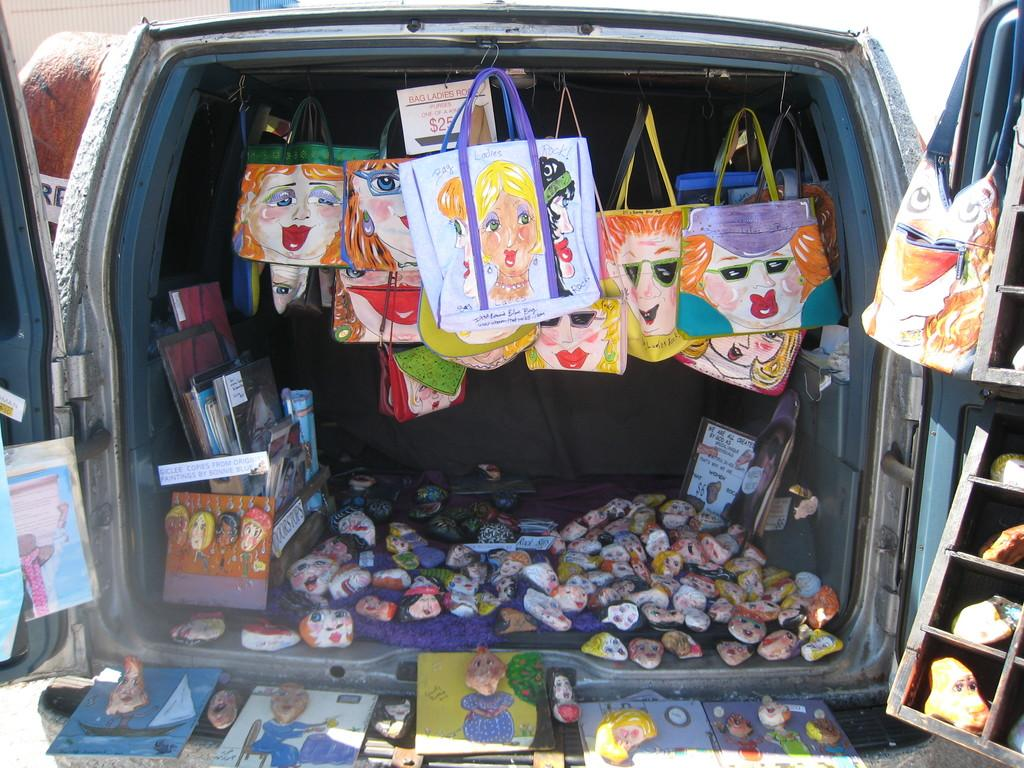What type of items can be seen in the car? There are cartoon bags, books, toys, rocks, papers, and stones in the car. Can you describe the contents of the car in more detail? The car contains a variety of items, including cartoon bags, books, toys, rocks, papers, and stones. What might be the purpose of the rocks and stones in the car? The purpose of the rocks and stones in the car is not specified, but they could be used as decoration, for a project, or simply as items that need to be transported. What type of pancake is being served in the car? There is no pancake present in the image; the car contains cartoon bags, books, toys, rocks, papers, and stones. Can you see a kitten playing with the toys in the car? There is no kitten present in the image; the car contains cartoon bags, books, toys, rocks, papers, and stones. 